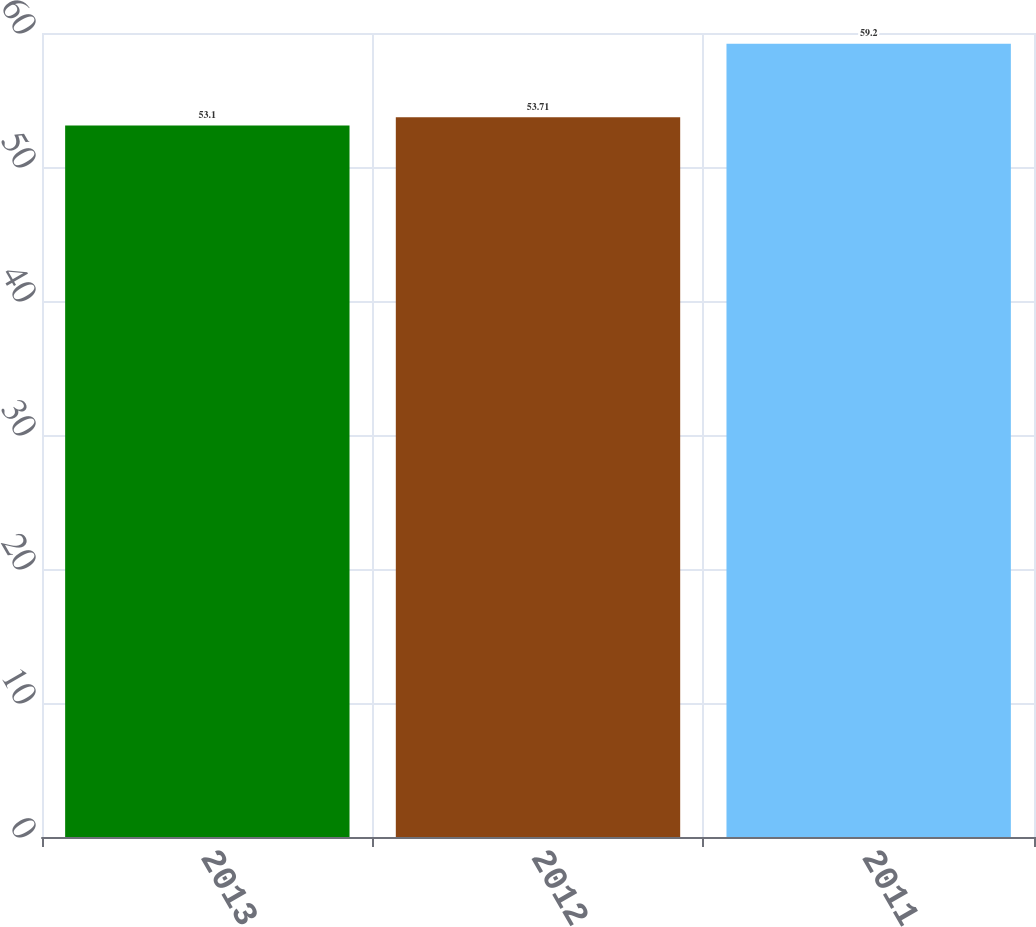<chart> <loc_0><loc_0><loc_500><loc_500><bar_chart><fcel>2013<fcel>2012<fcel>2011<nl><fcel>53.1<fcel>53.71<fcel>59.2<nl></chart> 